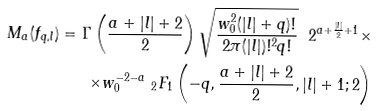<formula> <loc_0><loc_0><loc_500><loc_500>M _ { a } ( f _ { q , l } ) = \Gamma \left ( \frac { a + | l | + 2 } { 2 } \right ) \sqrt { \frac { w _ { 0 } ^ { 2 } ( | l | + q ) ! } { 2 \pi ( | l | ) ! ^ { 2 } q ! } } \ 2 ^ { a + \frac { | l | } { 2 } + 1 } \times \\ \times w _ { 0 } ^ { - 2 - a } \ _ { 2 } F _ { 1 } \left ( - q , \frac { a + | l | + 2 } { 2 } , | l | + 1 ; 2 \right ) \\</formula> 